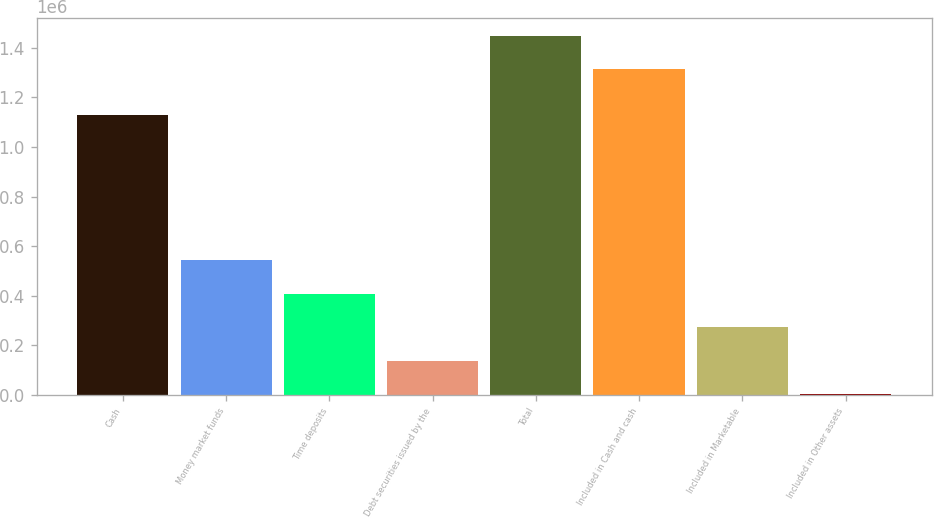Convert chart to OTSL. <chart><loc_0><loc_0><loc_500><loc_500><bar_chart><fcel>Cash<fcel>Money market funds<fcel>Time deposits<fcel>Debt securities issued by the<fcel>Total<fcel>Included in Cash and cash<fcel>Included in Marketable<fcel>Included in Other assets<nl><fcel>1.1272e+06<fcel>542406<fcel>407785<fcel>138543<fcel>1.44797e+06<fcel>1.31335e+06<fcel>273164<fcel>3922<nl></chart> 